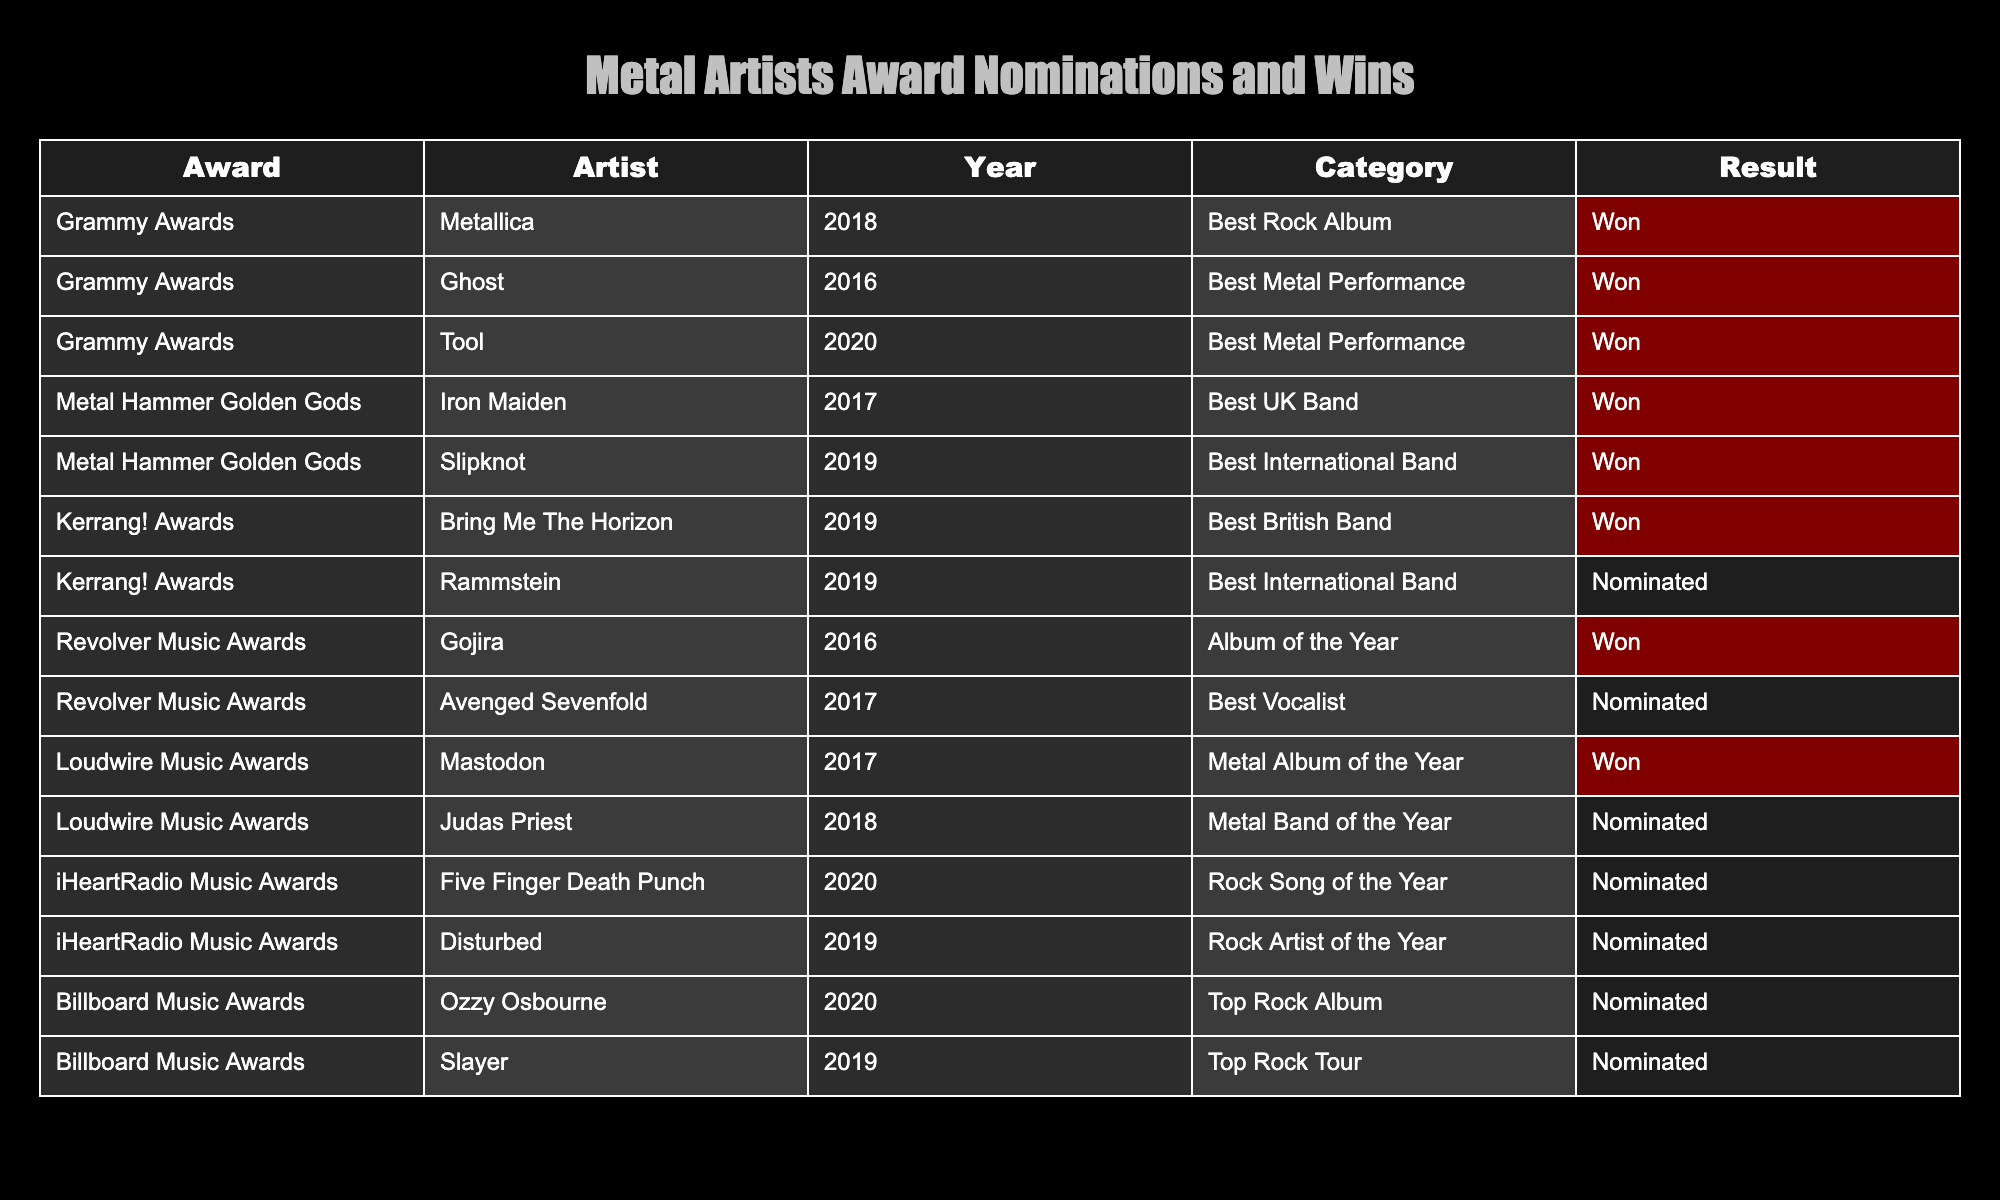What awards did Metallica win? The table indicates that Metallica won the Grammy Award for Best Rock Album in 2018.
Answer: Best Rock Album at the Grammy Awards How many nominations did Avenged Sevenfold receive? According to the table, Avenged Sevenfold received one nomination for Best Vocalist at the Revolver Music Awards in 2017.
Answer: One nomination Which artist won the most recent award in the table? The most recent award listed is for Tool, who won Best Metal Performance at the Grammy Awards in 2020.
Answer: Tool at the Grammy Awards in 2020 How many different awards are listed in the table? The table contains four distinct music awards: Grammy Awards, Metal Hammer Golden Gods, Kerrang! Awards, Revolver Music Awards, and Loudwire Music Awards.
Answer: Five Are there any artists in the table that have both won and been nominated for awards? Yes, Slipknot has won an award for Best International Band at the Metal Hammer Golden Gods in 2019 and also received a nomination for Best International Band at the Kerrang! Awards in 2019.
Answer: Yes What percentage of nominations resulted in wins for the artists listed in the table? There are 14 total nominations among the listed entries. The total wins are 8 (Metallica, Ghost, Tool, Iron Maiden, Slipknot, Bring Me The Horizon, Gojira, and Mastodon), so the percentage of wins is (8/14)*100 = 57.14%.
Answer: Approximately 57% Did any artist win at both the Kerrang! Awards and the Metal Hammer Golden Gods in the same year? No, the artists listed for both awards do not overlap in any single year; thus, no artist won at both in the same year.
Answer: No Which year had the least amount of wins for metal artists? Analyzing the years, 2016 and 2019 each have only one win; therefore, 2016 and 2019 had the least amount of wins.
Answer: 2016 and 2019 Who won Best UK Band at the Metal Hammer Golden Gods? The table lists Iron Maiden as the winner of Best UK Band at the Metal Hammer Golden Gods in 2017.
Answer: Iron Maiden 